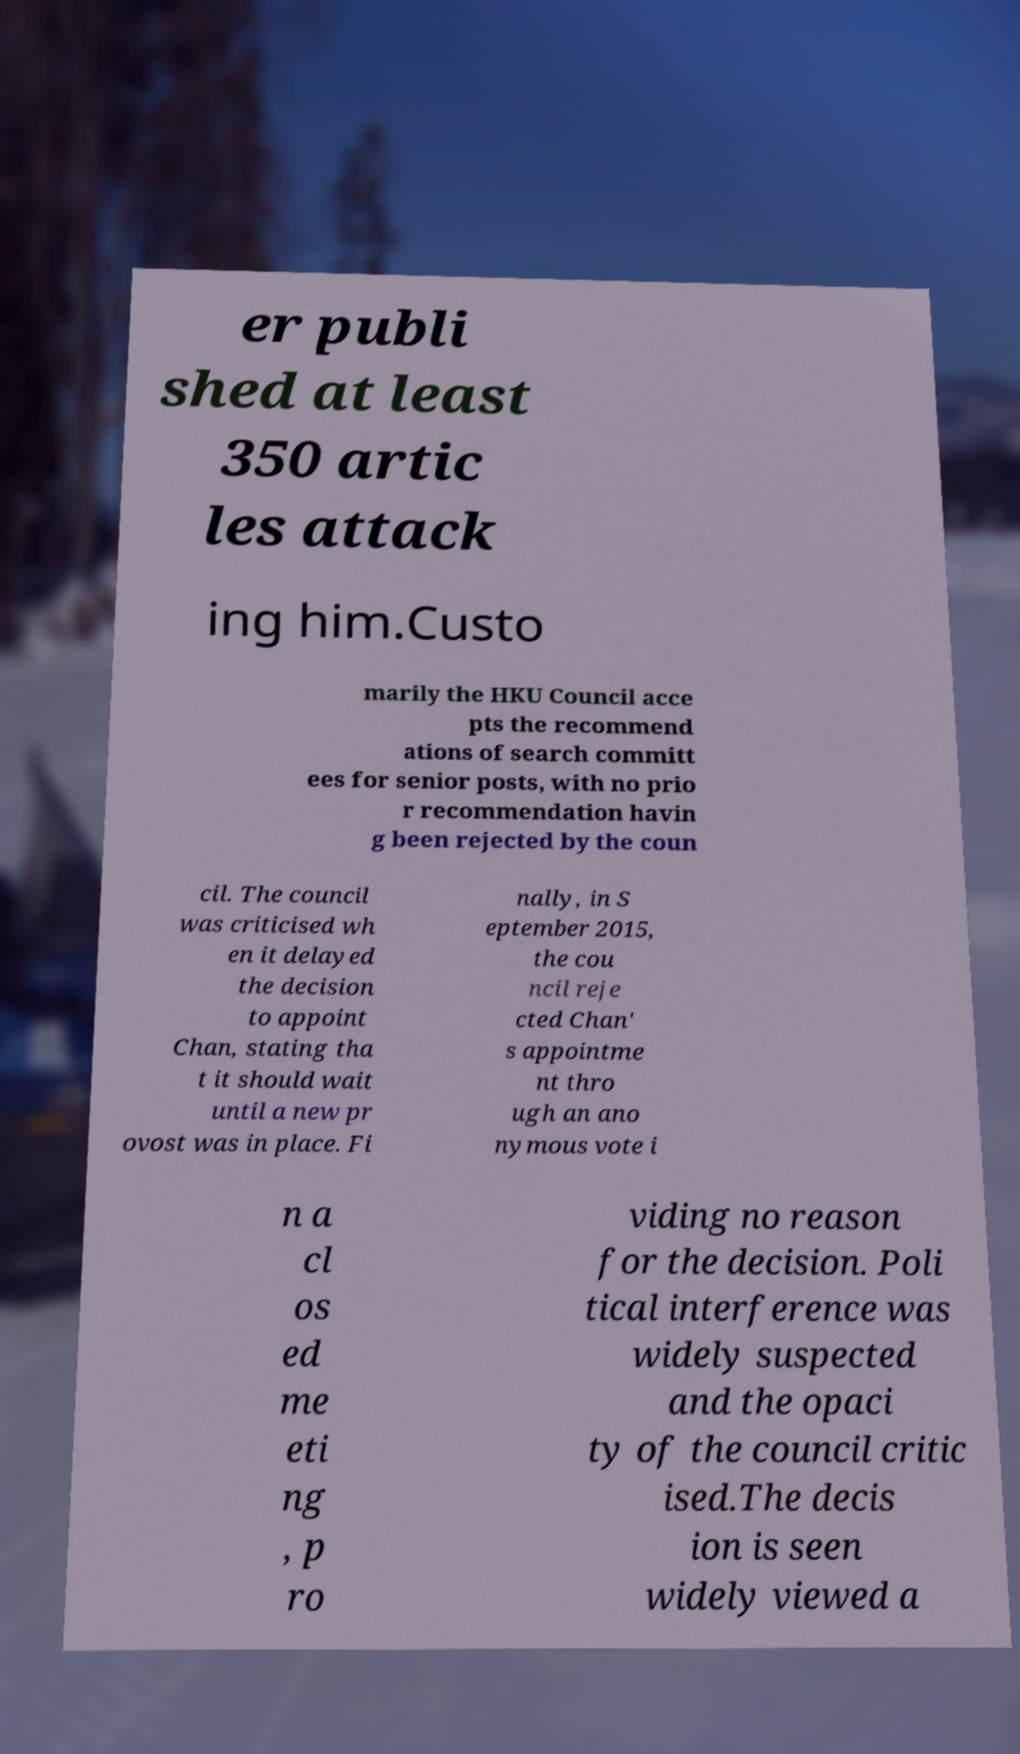Can you read and provide the text displayed in the image?This photo seems to have some interesting text. Can you extract and type it out for me? er publi shed at least 350 artic les attack ing him.Custo marily the HKU Council acce pts the recommend ations of search committ ees for senior posts, with no prio r recommendation havin g been rejected by the coun cil. The council was criticised wh en it delayed the decision to appoint Chan, stating tha t it should wait until a new pr ovost was in place. Fi nally, in S eptember 2015, the cou ncil reje cted Chan' s appointme nt thro ugh an ano nymous vote i n a cl os ed me eti ng , p ro viding no reason for the decision. Poli tical interference was widely suspected and the opaci ty of the council critic ised.The decis ion is seen widely viewed a 